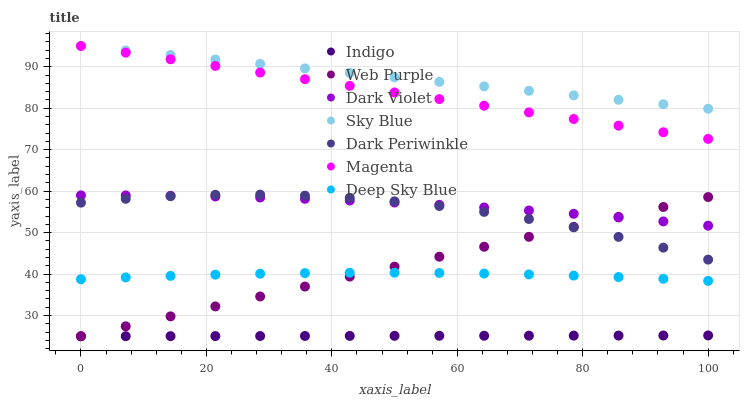Does Indigo have the minimum area under the curve?
Answer yes or no. Yes. Does Sky Blue have the maximum area under the curve?
Answer yes or no. Yes. Does Dark Violet have the minimum area under the curve?
Answer yes or no. No. Does Dark Violet have the maximum area under the curve?
Answer yes or no. No. Is Sky Blue the smoothest?
Answer yes or no. Yes. Is Dark Periwinkle the roughest?
Answer yes or no. Yes. Is Dark Violet the smoothest?
Answer yes or no. No. Is Dark Violet the roughest?
Answer yes or no. No. Does Indigo have the lowest value?
Answer yes or no. Yes. Does Dark Violet have the lowest value?
Answer yes or no. No. Does Magenta have the highest value?
Answer yes or no. Yes. Does Dark Violet have the highest value?
Answer yes or no. No. Is Deep Sky Blue less than Dark Periwinkle?
Answer yes or no. Yes. Is Dark Periwinkle greater than Deep Sky Blue?
Answer yes or no. Yes. Does Deep Sky Blue intersect Web Purple?
Answer yes or no. Yes. Is Deep Sky Blue less than Web Purple?
Answer yes or no. No. Is Deep Sky Blue greater than Web Purple?
Answer yes or no. No. Does Deep Sky Blue intersect Dark Periwinkle?
Answer yes or no. No. 